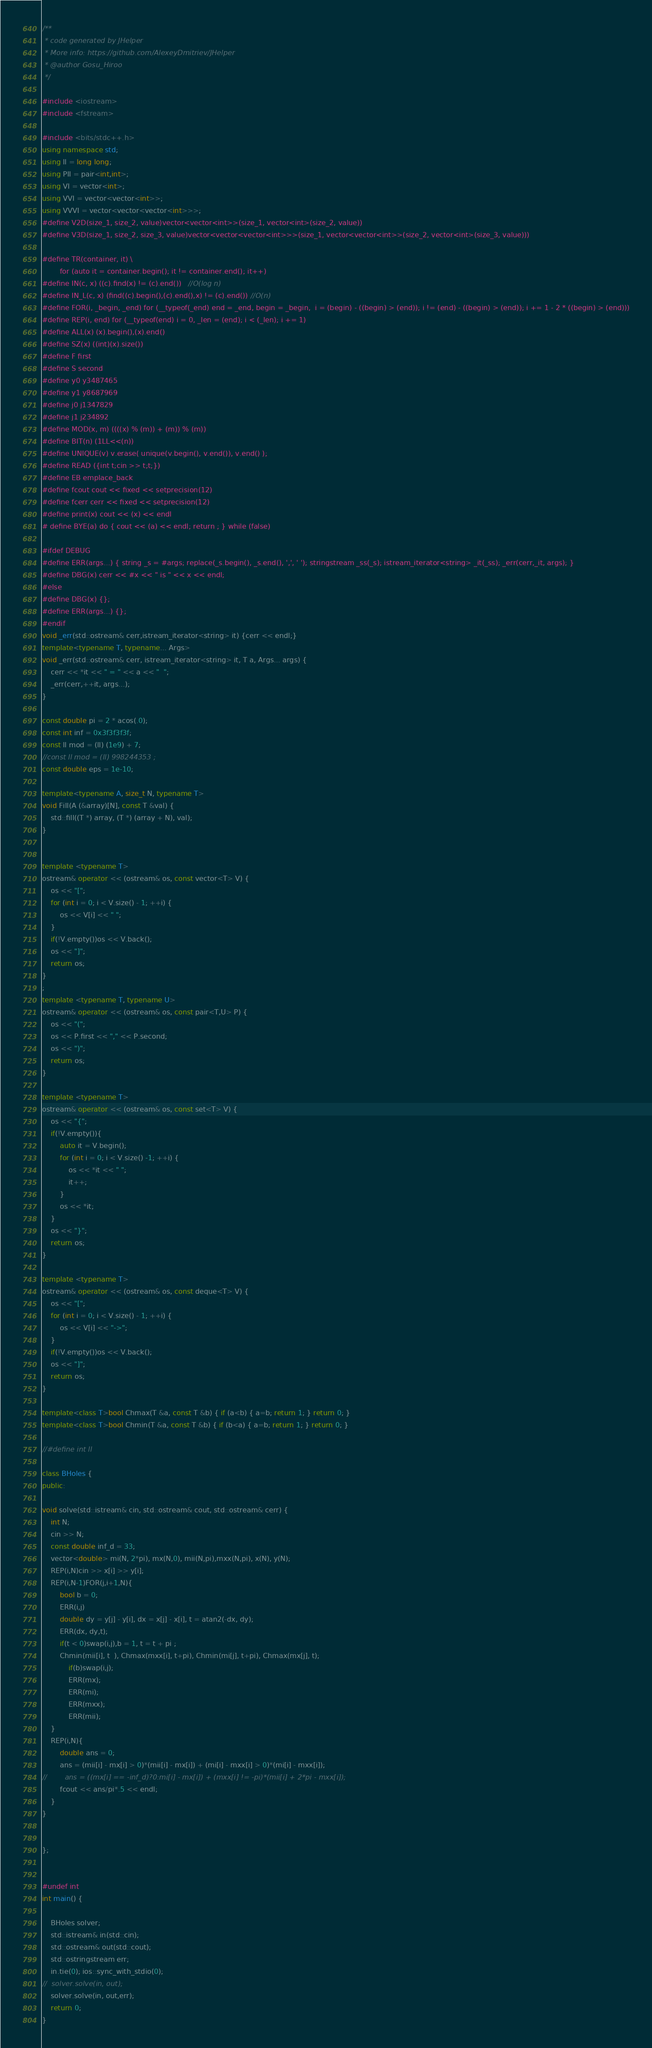Convert code to text. <code><loc_0><loc_0><loc_500><loc_500><_C++_>/**
 * code generated by JHelper
 * More info: https://github.com/AlexeyDmitriev/JHelper
 * @author Gosu_Hiroo
 */

#include <iostream>
#include <fstream>

#include <bits/stdc++.h>
using namespace std;
using ll = long long;
using PII = pair<int,int>;
using VI = vector<int>;
using VVI = vector<vector<int>>;
using VVVI = vector<vector<vector<int>>>;
#define V2D(size_1, size_2, value)vector<vector<int>>(size_1, vector<int>(size_2, value))
#define V3D(size_1, size_2, size_3, value)vector<vector<vector<int>>>(size_1, vector<vector<int>>(size_2, vector<int>(size_3, value)))

#define TR(container, it) \
        for (auto it = container.begin(); it != container.end(); it++)
#define IN(c, x) ((c).find(x) != (c).end())   //O(log n)
#define IN_L(c, x) (find((c).begin(),(c).end(),x) != (c).end()) //O(n)
#define FOR(i, _begin, _end) for (__typeof(_end) end = _end, begin = _begin,  i = (begin) - ((begin) > (end)); i != (end) - ((begin) > (end)); i += 1 - 2 * ((begin) > (end)))
#define REP(i, end) for (__typeof(end) i = 0, _len = (end); i < (_len); i += 1)
#define ALL(x) (x).begin(),(x).end()
#define SZ(x) ((int)(x).size())
#define F first
#define S second
#define y0 y3487465
#define y1 y8687969
#define j0 j1347829
#define j1 j234892
#define MOD(x, m) ((((x) % (m)) + (m)) % (m))
#define BIT(n) (1LL<<(n))
#define UNIQUE(v) v.erase( unique(v.begin(), v.end()), v.end() );
#define READ ({int t;cin >> t;t;})
#define EB emplace_back
#define fcout cout << fixed << setprecision(12)
#define fcerr cerr << fixed << setprecision(12)
#define print(x) cout << (x) << endl
# define BYE(a) do { cout << (a) << endl; return ; } while (false)

#ifdef DEBUG
#define ERR(args...) { string _s = #args; replace(_s.begin(), _s.end(), ',', ' '); stringstream _ss(_s); istream_iterator<string> _it(_ss); _err(cerr,_it, args); }
#define DBG(x) cerr << #x << " is " << x << endl;
#else
#define DBG(x) {};
#define ERR(args...) {};
#endif
void _err(std::ostream& cerr,istream_iterator<string> it) {cerr << endl;}
template<typename T, typename... Args>
void _err(std::ostream& cerr, istream_iterator<string> it, T a, Args... args) {
    cerr << *it << " = " << a << "  ";
    _err(cerr,++it, args...);
}

const double pi = 2 * acos(.0);
const int inf = 0x3f3f3f3f;
const ll mod = (ll) (1e9) + 7;
//const ll mod = (ll) 998244353 ;
const double eps = 1e-10;

template<typename A, size_t N, typename T>
void Fill(A (&array)[N], const T &val) {
    std::fill((T *) array, (T *) (array + N), val);
}


template <typename T>
ostream& operator << (ostream& os, const vector<T> V) {
    os << "[";
    for (int i = 0; i < V.size() - 1; ++i) {
        os << V[i] << " ";
    }
    if(!V.empty())os << V.back();
    os << "]";
    return os;
}
;
template <typename T, typename U>
ostream& operator << (ostream& os, const pair<T,U> P) {
    os << "(";
    os << P.first << "," << P.second;
    os << ")";
    return os;
}

template <typename T>
ostream& operator << (ostream& os, const set<T> V) {
    os << "{";
    if(!V.empty()){
        auto it = V.begin();
        for (int i = 0; i < V.size() -1; ++i) {
            os << *it << " ";
            it++;
        }
        os << *it;
    }
    os << "}";
    return os;
}

template <typename T>
ostream& operator << (ostream& os, const deque<T> V) {
    os << "[";
    for (int i = 0; i < V.size() - 1; ++i) {
        os << V[i] << "->";
    }
    if(!V.empty())os << V.back();
    os << "]";
    return os;
}

template<class T>bool Chmax(T &a, const T &b) { if (a<b) { a=b; return 1; } return 0; }
template<class T>bool Chmin(T &a, const T &b) { if (b<a) { a=b; return 1; } return 0; }

//#define int ll

class BHoles {
public:

void solve(std::istream& cin, std::ostream& cout, std::ostream& cerr) {
    int N;
    cin >> N;
    const double inf_d = 33;
    vector<double> mi(N, 2*pi), mx(N,0), mii(N,pi),mxx(N,pi), x(N), y(N);
    REP(i,N)cin >> x[i] >> y[i];
    REP(i,N-1)FOR(j,i+1,N){
        bool b = 0;
        ERR(i,j)
        double dy = y[j] - y[i], dx = x[j] - x[i], t = atan2(-dx, dy);
        ERR(dx, dy,t);
        if(t < 0)swap(i,j),b = 1, t = t + pi ;
        Chmin(mii[i], t  ), Chmax(mxx[i], t+pi), Chmin(mi[j], t+pi), Chmax(mx[j], t);
            if(b)swap(i,j);
            ERR(mx);
            ERR(mi);
            ERR(mxx);
            ERR(mii);
    }
    REP(i,N){
        double ans = 0;
        ans = (mii[i] - mx[i] > 0)*(mii[i] - mx[i]) + (mi[i] - mxx[i] > 0)*(mi[i] - mxx[i]);
//        ans = ((mx[i] == -inf_d)?0:mi[i] - mx[i]) + (mxx[i] != -pi)*(mii[i] + 2*pi - mxx[i]);
        fcout << ans/pi*.5 << endl;
    }
}


};


#undef int
int main() {

	BHoles solver;
	std::istream& in(std::cin);
	std::ostream& out(std::cout);
    std::ostringstream err;
	in.tie(0); ios::sync_with_stdio(0);
//	solver.solve(in, out);
    solver.solve(in, out,err);
	return 0;
}
</code> 